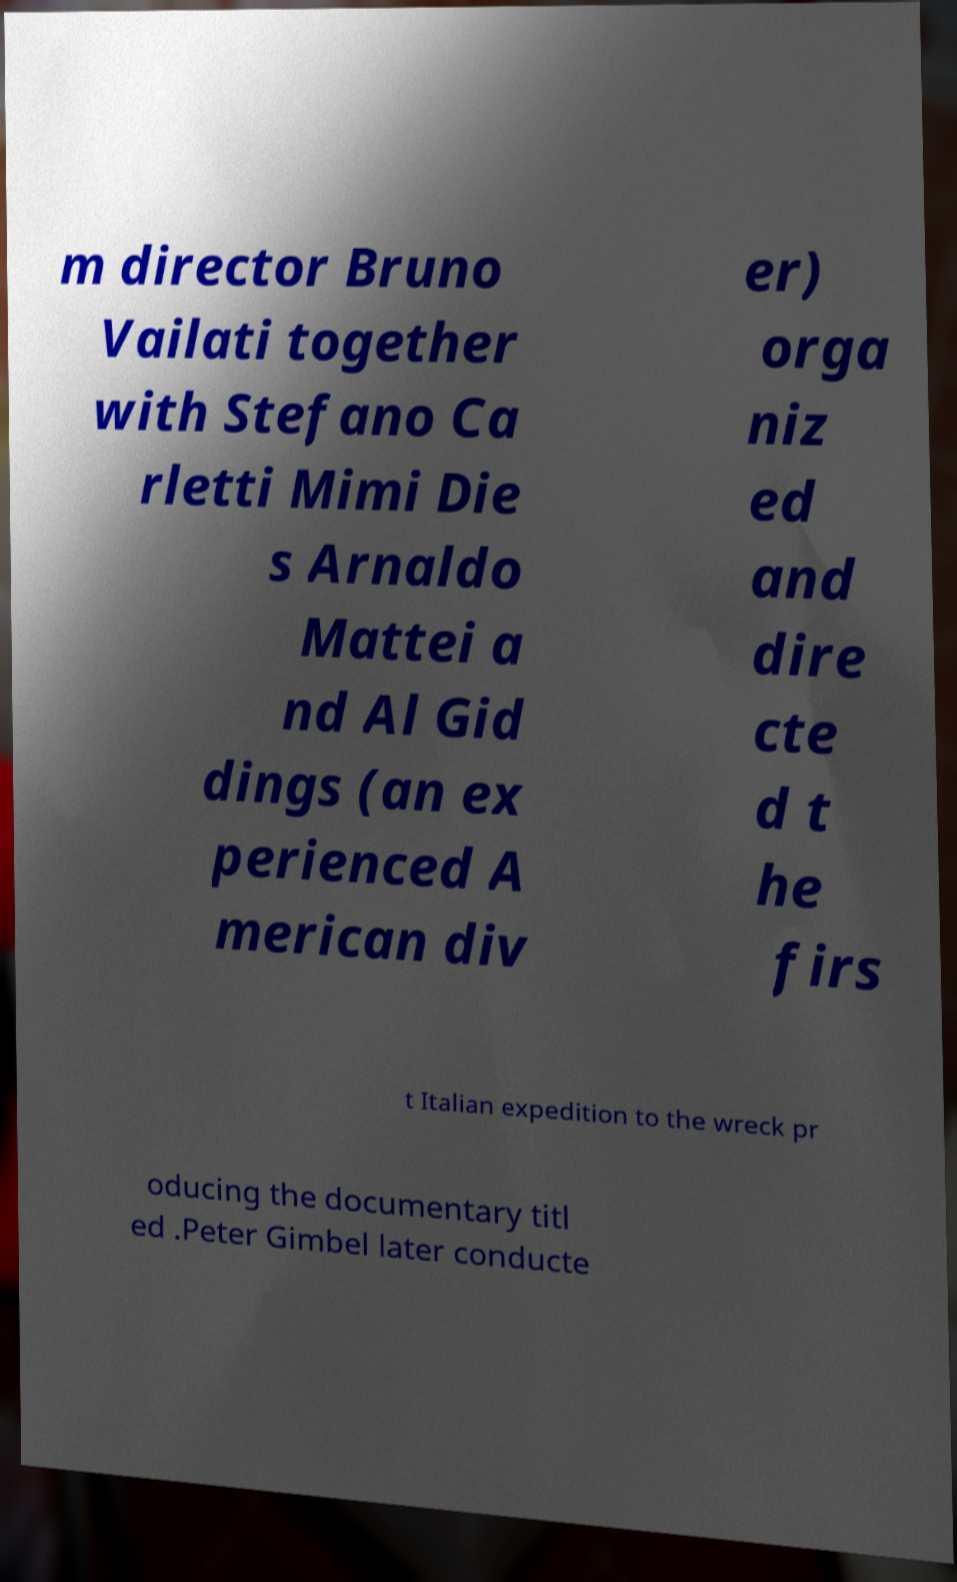Please read and relay the text visible in this image. What does it say? m director Bruno Vailati together with Stefano Ca rletti Mimi Die s Arnaldo Mattei a nd Al Gid dings (an ex perienced A merican div er) orga niz ed and dire cte d t he firs t Italian expedition to the wreck pr oducing the documentary titl ed .Peter Gimbel later conducte 